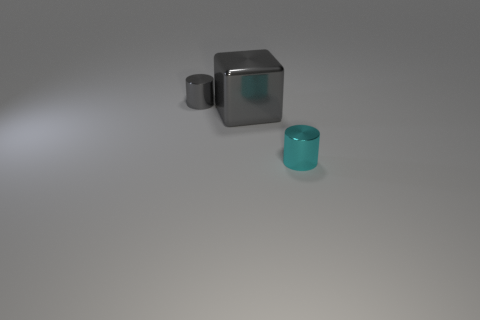What is the material of the small cylinder left of the gray metal object that is to the right of the tiny gray metallic cylinder?
Keep it short and to the point. Metal. How many other objects are there of the same material as the cyan cylinder?
Provide a short and direct response. 2. There is a cyan thing that is the same size as the gray metal cylinder; what material is it?
Offer a terse response. Metal. Are there more cyan objects that are to the right of the tiny gray metal thing than tiny shiny cylinders behind the large gray thing?
Your answer should be compact. No. Is there a blue shiny thing of the same shape as the small gray metal object?
Offer a very short reply. No. There is a thing that is the same size as the gray metallic cylinder; what is its shape?
Keep it short and to the point. Cylinder. What shape is the tiny metallic object in front of the gray shiny cylinder?
Your response must be concise. Cylinder. Is the number of small metallic cylinders left of the gray block less than the number of metal blocks left of the tiny gray shiny object?
Provide a short and direct response. No. There is a cube; is it the same size as the object on the right side of the large object?
Your response must be concise. No. What number of other cyan metallic cylinders have the same size as the cyan shiny cylinder?
Offer a terse response. 0. 